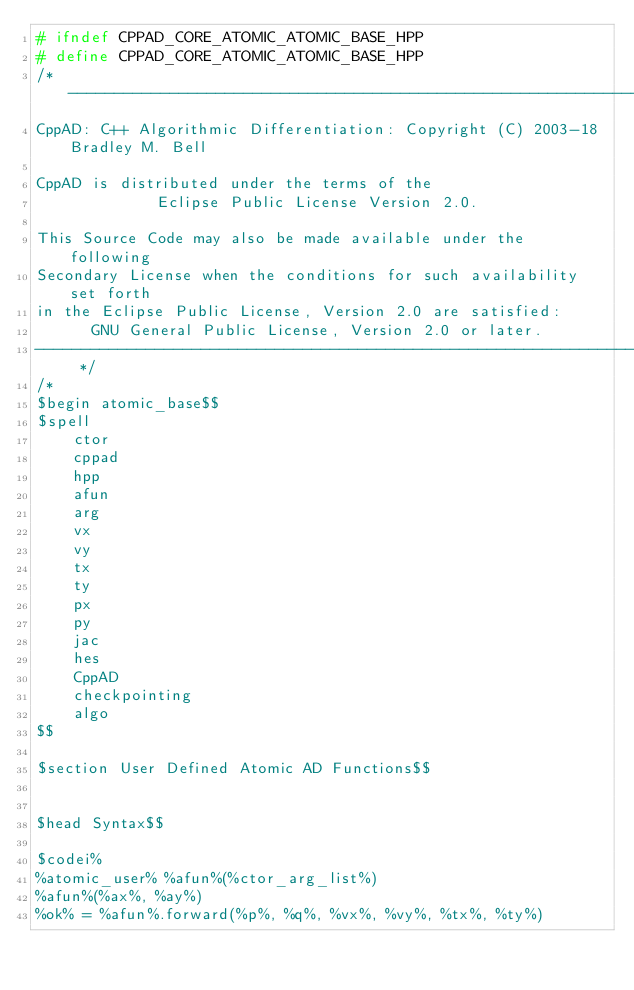<code> <loc_0><loc_0><loc_500><loc_500><_C++_># ifndef CPPAD_CORE_ATOMIC_ATOMIC_BASE_HPP
# define CPPAD_CORE_ATOMIC_ATOMIC_BASE_HPP
/* --------------------------------------------------------------------------
CppAD: C++ Algorithmic Differentiation: Copyright (C) 2003-18 Bradley M. Bell

CppAD is distributed under the terms of the
             Eclipse Public License Version 2.0.

This Source Code may also be made available under the following
Secondary License when the conditions for such availability set forth
in the Eclipse Public License, Version 2.0 are satisfied:
      GNU General Public License, Version 2.0 or later.
---------------------------------------------------------------------------- */
/*
$begin atomic_base$$
$spell
    ctor
    cppad
    hpp
    afun
    arg
    vx
    vy
    tx
    ty
    px
    py
    jac
    hes
    CppAD
    checkpointing
    algo
$$

$section User Defined Atomic AD Functions$$


$head Syntax$$

$codei%
%atomic_user% %afun%(%ctor_arg_list%)
%afun%(%ax%, %ay%)
%ok% = %afun%.forward(%p%, %q%, %vx%, %vy%, %tx%, %ty%)</code> 